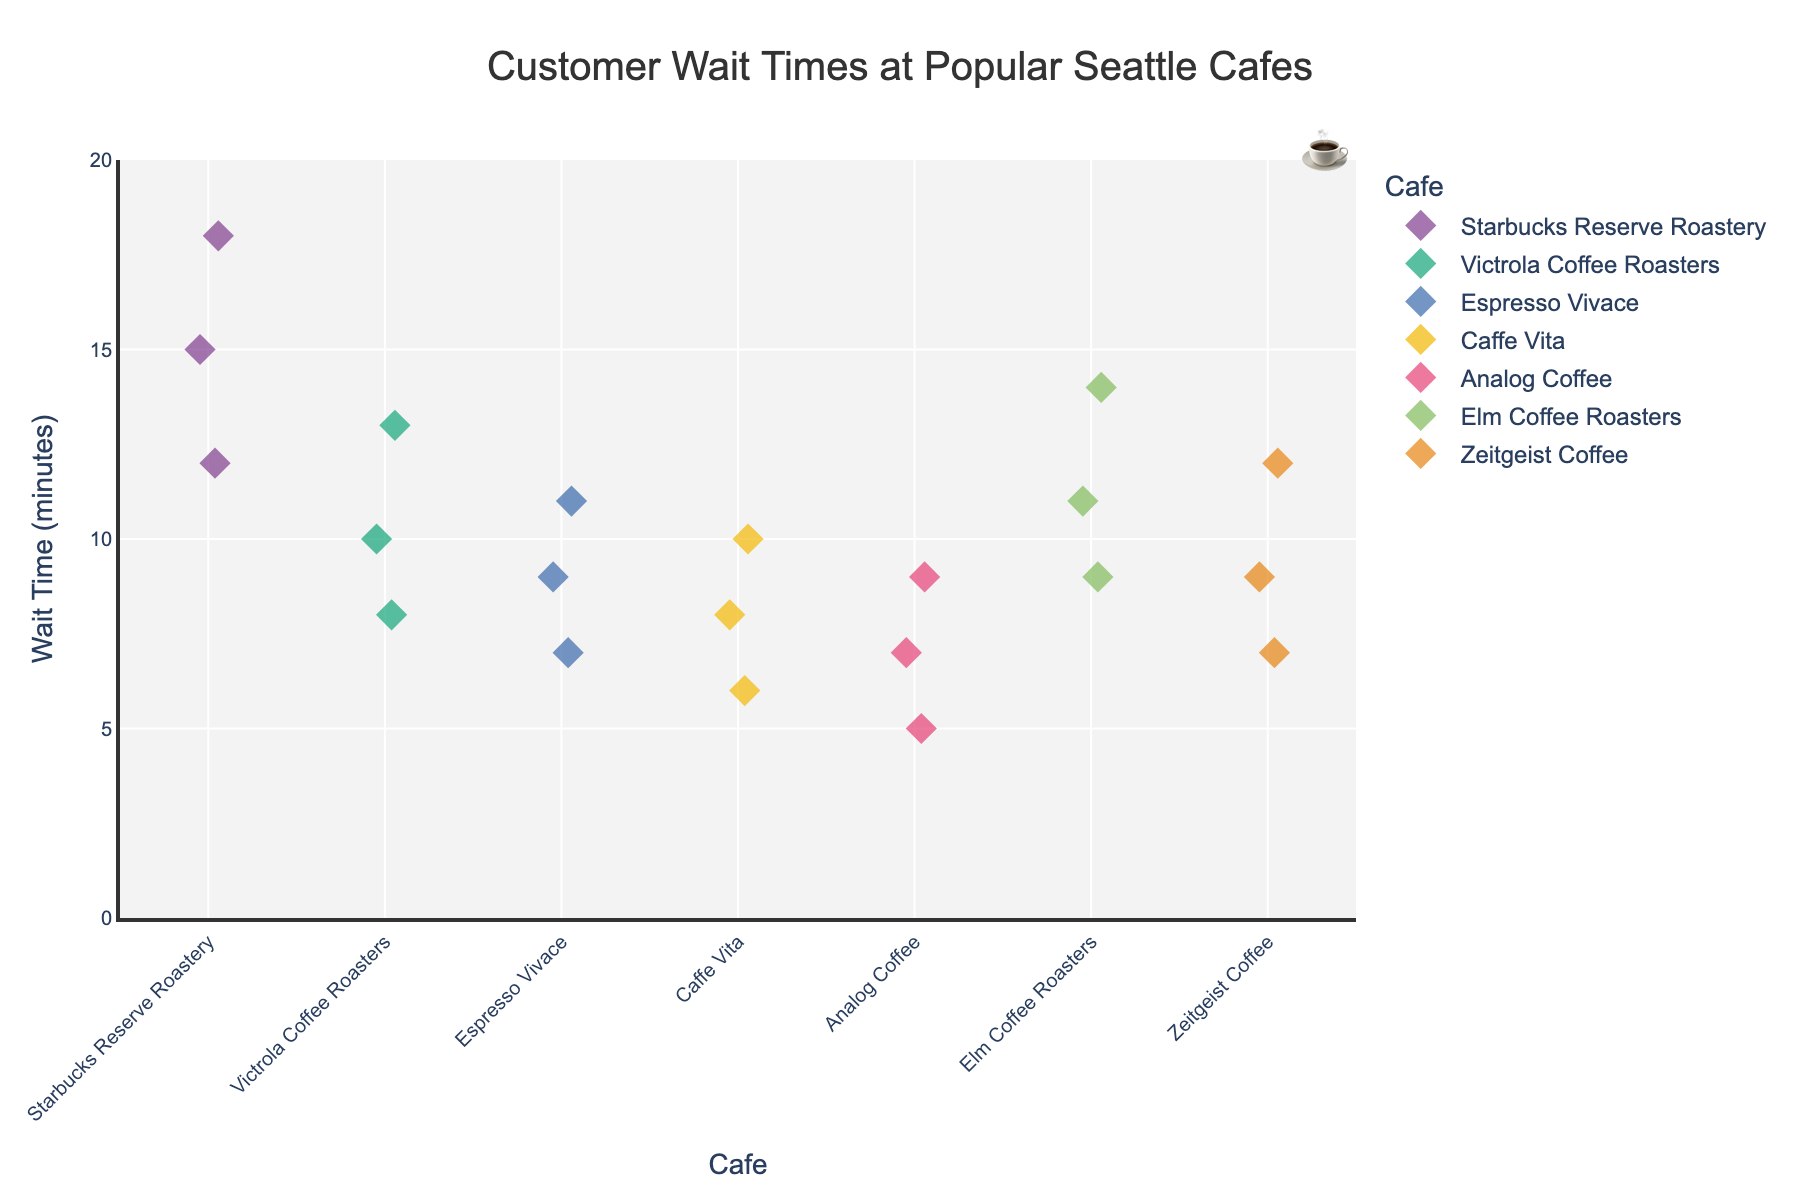What's the title of the plot? The title of the plot is usually displayed at the top center of the figure, so we can directly read it from there.
Answer: Customer Wait Times at Popular Seattle Cafes What does the Y-axis represent? The Y-axis label is visible along the vertical axis of the plot, indicating what is measured.
Answer: Wait Time (minutes) Which cafe has the highest wait time recorded? By observing the maximum points on the Y-axis for each cafe, we identify Starbucks Reserve Roastery with the highest wait time of 18 minutes.
Answer: Starbucks Reserve Roastery Which cafe has the lowest wait time recorded? By observing the minimum points on the Y-axis for each cafe, we.find Analog Coffee with the lowest wait time of 5 minutes.
Answer: Analog Coffee What's the average wait time for Victrola Coffee Roasters? Victrola Coffee Roasters has wait times of 8, 10, and 13. The average is calculated as (8+10+13)/3.
Answer: 10.33 minutes Which cafe has the most data points? Count the number of data points for each cafe. Starbucks Reserve Roastery has 3, Victrola Coffee Roasters has 3, Espresso Vivace has 3, Caffe Vita has 3, Analog Coffee has 3, Elm Coffee Roasters has 3, and Zeitgeist Coffee has 3. Hence, all cafes have the same number of data points.
Answer: All cafes have the same number of data points Which cafe has the narrowest range of wait times? Determine the range by subtracting the minimum from the maximum wait time for each cafe. Analog Coffee has the narrowest range of 4 minutes (9 - 5).
Answer: Analog Coffee How does the wait time at Espresso Vivace compare to Elm Coffee Roasters? Compare the data points for the two cafes. Espresso Vivace's wait times are 7, 9, 11; Elm Coffee Roasters' wait times are 9, 11, 14. Elm Coffee Roasters generally has higher wait times.
Answer: Elm Coffee Roasters generally has higher wait times Which cafes have wait times exceeding 10 minutes? Identify all points exceeding 10 on the Y-axis. Starbucks Reserve Roastery, Victrola Coffee Roasters, Espresso Vivace, Elm Coffee Roasters, and Zeitgeist Coffee have wait times above 10 minutes.
Answer: Starbucks Reserve Roastery, Victrola Coffee Roasters, Espresso Vivace, Elm Coffee Roasters, Zeitgeist Coffee Which cafe has the most dispersed wait times? Determine the dispersion by assessing the spread of the points along the Y-axis for each cafe. Starbucks Reserve Roastery has the most dispersed wait times ranging from 12 to 18 minutes.
Answer: Starbucks Reserve Roastery 